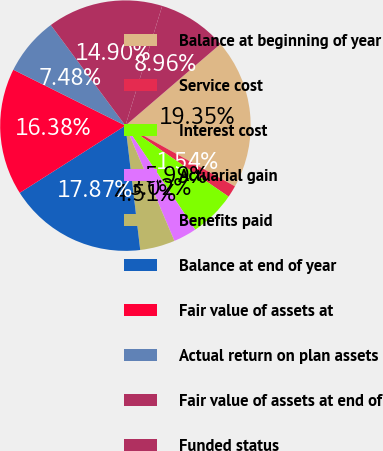Convert chart to OTSL. <chart><loc_0><loc_0><loc_500><loc_500><pie_chart><fcel>Balance at beginning of year<fcel>Service cost<fcel>Interest cost<fcel>Actuarial gain<fcel>Benefits paid<fcel>Balance at end of year<fcel>Fair value of assets at<fcel>Actual return on plan assets<fcel>Fair value of assets at end of<fcel>Funded status<nl><fcel>19.35%<fcel>1.54%<fcel>5.99%<fcel>3.02%<fcel>4.51%<fcel>17.87%<fcel>16.38%<fcel>7.48%<fcel>14.9%<fcel>8.96%<nl></chart> 